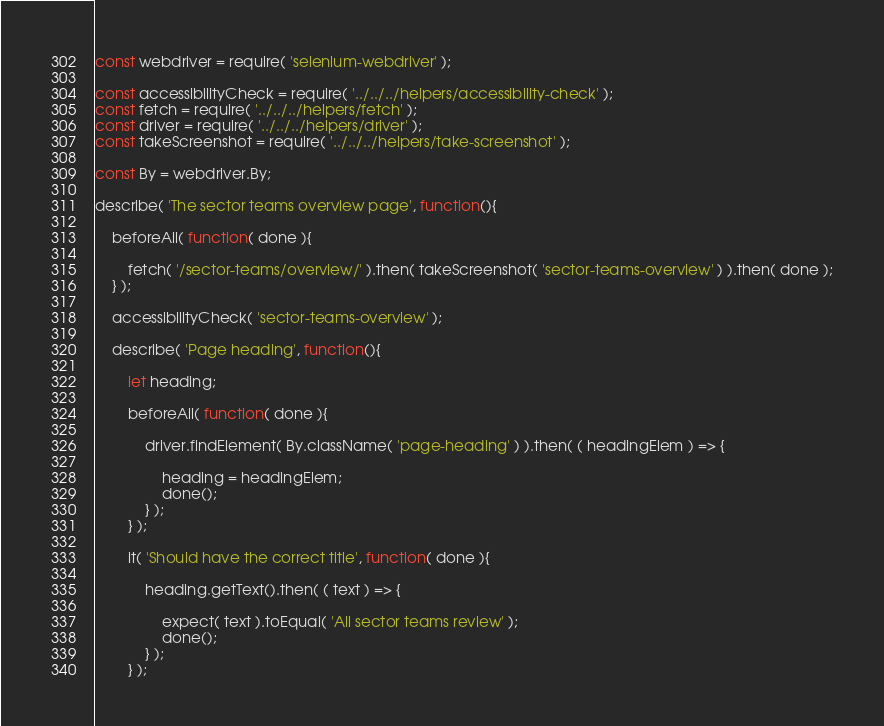<code> <loc_0><loc_0><loc_500><loc_500><_JavaScript_>const webdriver = require( 'selenium-webdriver' );

const accessibilityCheck = require( '../../../helpers/accessibility-check' );
const fetch = require( '../../../helpers/fetch' );
const driver = require( '../../../helpers/driver' );
const takeScreenshot = require( '../../../helpers/take-screenshot' );

const By = webdriver.By;

describe( 'The sector teams overview page', function(){

	beforeAll( function( done ){

		fetch( '/sector-teams/overview/' ).then( takeScreenshot( 'sector-teams-overview' ) ).then( done );
	} );

	accessibilityCheck( 'sector-teams-overview' );

	describe( 'Page heading', function(){

		let heading;

		beforeAll( function( done ){

			driver.findElement( By.className( 'page-heading' ) ).then( ( headingElem ) => {

				heading = headingElem;
				done();
			} );
		} );

		it( 'Should have the correct title', function( done ){

			heading.getText().then( ( text ) => {

				expect( text ).toEqual( 'All sector teams review' );
				done();
			} );
		} );
</code> 